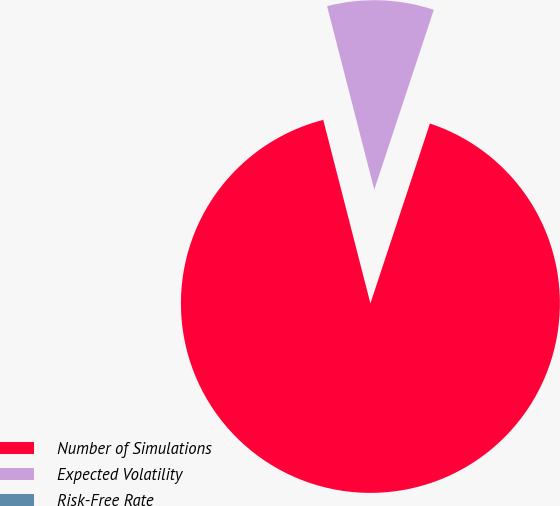<chart> <loc_0><loc_0><loc_500><loc_500><pie_chart><fcel>Number of Simulations<fcel>Expected Volatility<fcel>Risk-Free Rate<nl><fcel>90.91%<fcel>9.09%<fcel>0.0%<nl></chart> 